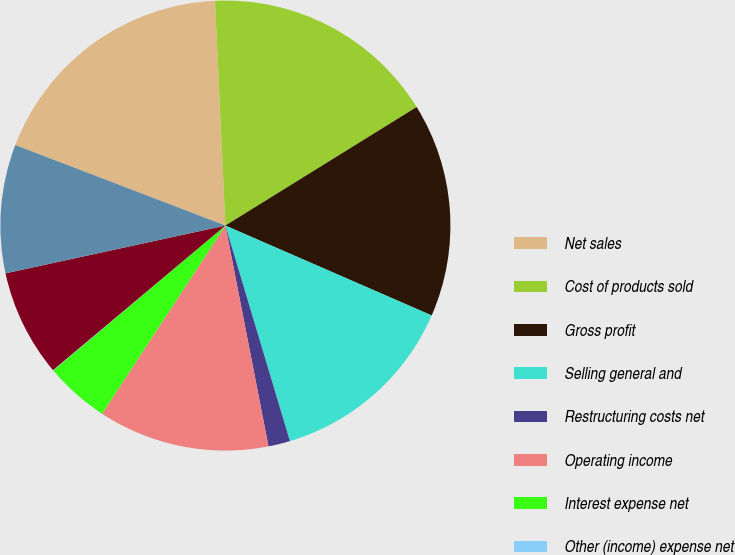Convert chart. <chart><loc_0><loc_0><loc_500><loc_500><pie_chart><fcel>Net sales<fcel>Cost of products sold<fcel>Gross profit<fcel>Selling general and<fcel>Restructuring costs net<fcel>Operating income<fcel>Interest expense net<fcel>Other (income) expense net<fcel>Net nonoperating expenses<fcel>Income before income taxes<nl><fcel>18.44%<fcel>16.9%<fcel>15.37%<fcel>13.83%<fcel>1.56%<fcel>12.3%<fcel>4.63%<fcel>0.03%<fcel>7.7%<fcel>9.23%<nl></chart> 